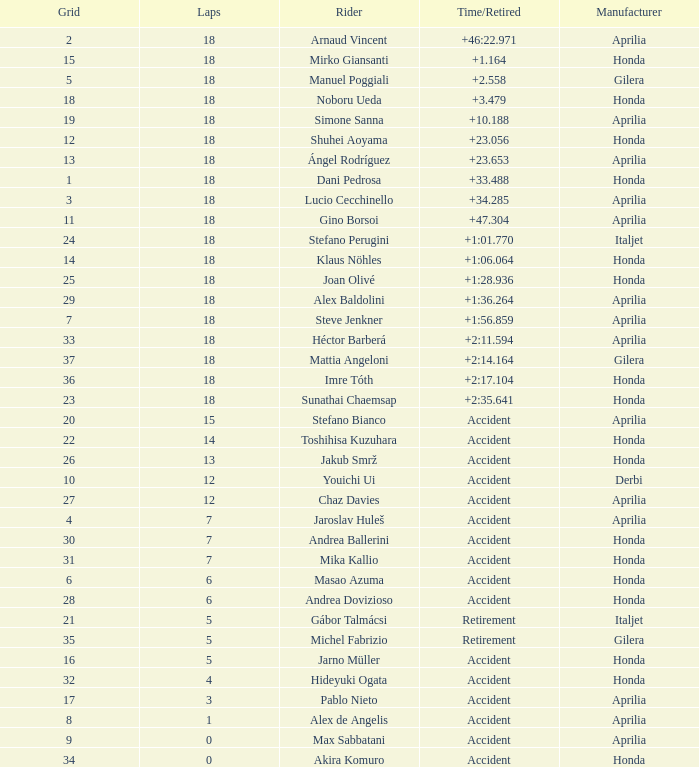What is the time/retired of the honda manufacturer with a grid less than 26, 18 laps, and joan olivé as the rider? +1:28.936. 